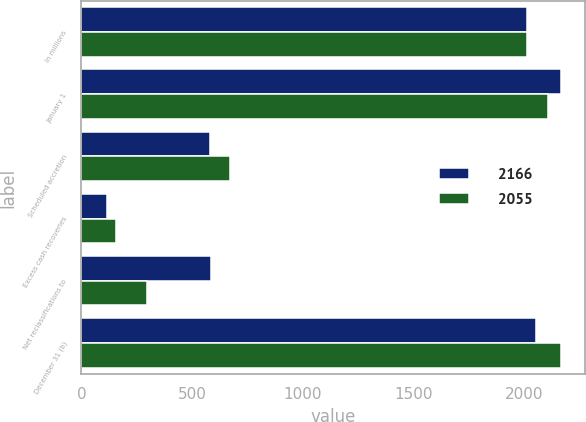<chart> <loc_0><loc_0><loc_500><loc_500><stacked_bar_chart><ecel><fcel>In millions<fcel>January 1<fcel>Scheduled accretion<fcel>Excess cash recoveries<fcel>Net reclassifications to<fcel>December 31 (b)<nl><fcel>2166<fcel>2013<fcel>2166<fcel>580<fcel>115<fcel>584<fcel>2055<nl><fcel>2055<fcel>2012<fcel>2109<fcel>671<fcel>157<fcel>298<fcel>2166<nl></chart> 